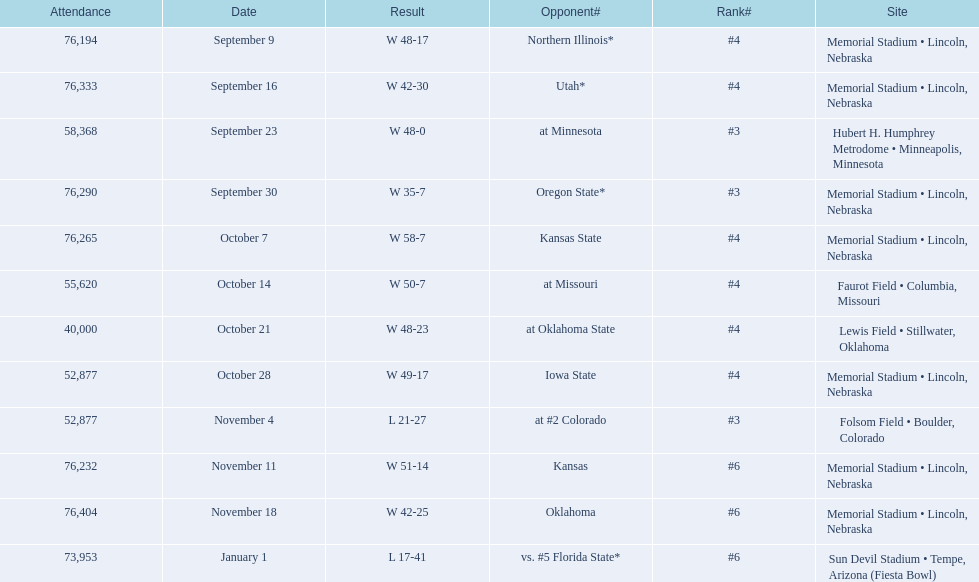Who were all of their opponents? Northern Illinois*, Utah*, at Minnesota, Oregon State*, Kansas State, at Missouri, at Oklahoma State, Iowa State, at #2 Colorado, Kansas, Oklahoma, vs. #5 Florida State*. And what was the attendance of these games? 76,194, 76,333, 58,368, 76,290, 76,265, 55,620, 40,000, 52,877, 52,877, 76,232, 76,404, 73,953. Of those numbers, which is associated with the oregon state game? 76,290. 